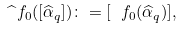<formula> <loc_0><loc_0><loc_500><loc_500>\widehat { \ } f _ { 0 } ( [ \widehat { \alpha } _ { q } ] ) \colon = [ \ f _ { 0 } ( \widehat { \alpha } _ { q } ) ] ,</formula> 